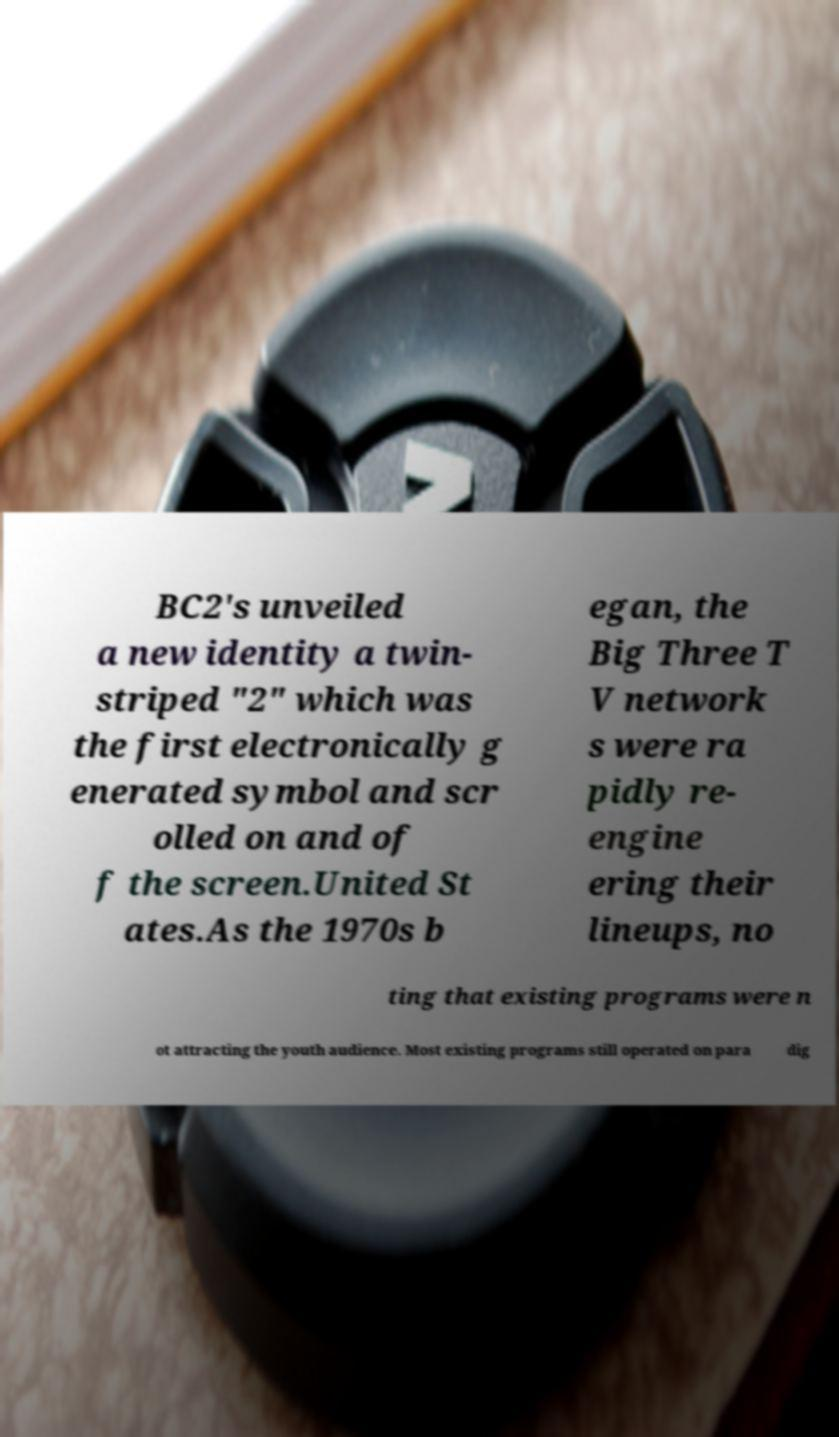What messages or text are displayed in this image? I need them in a readable, typed format. BC2's unveiled a new identity a twin- striped "2" which was the first electronically g enerated symbol and scr olled on and of f the screen.United St ates.As the 1970s b egan, the Big Three T V network s were ra pidly re- engine ering their lineups, no ting that existing programs were n ot attracting the youth audience. Most existing programs still operated on para dig 